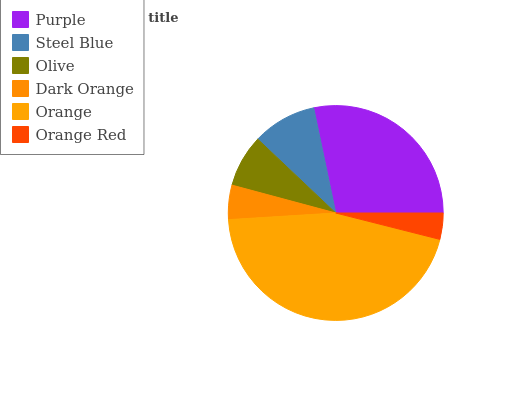Is Orange Red the minimum?
Answer yes or no. Yes. Is Orange the maximum?
Answer yes or no. Yes. Is Steel Blue the minimum?
Answer yes or no. No. Is Steel Blue the maximum?
Answer yes or no. No. Is Purple greater than Steel Blue?
Answer yes or no. Yes. Is Steel Blue less than Purple?
Answer yes or no. Yes. Is Steel Blue greater than Purple?
Answer yes or no. No. Is Purple less than Steel Blue?
Answer yes or no. No. Is Steel Blue the high median?
Answer yes or no. Yes. Is Olive the low median?
Answer yes or no. Yes. Is Orange the high median?
Answer yes or no. No. Is Purple the low median?
Answer yes or no. No. 